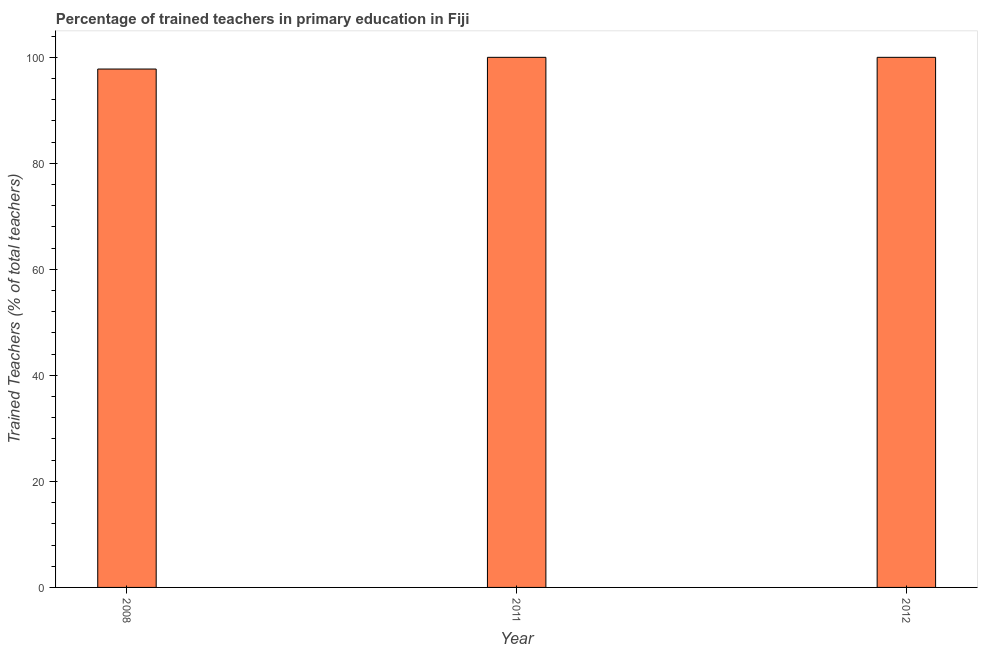Does the graph contain grids?
Offer a terse response. No. What is the title of the graph?
Offer a very short reply. Percentage of trained teachers in primary education in Fiji. What is the label or title of the X-axis?
Make the answer very short. Year. What is the label or title of the Y-axis?
Give a very brief answer. Trained Teachers (% of total teachers). What is the percentage of trained teachers in 2011?
Keep it short and to the point. 100. Across all years, what is the minimum percentage of trained teachers?
Offer a terse response. 97.79. What is the sum of the percentage of trained teachers?
Your response must be concise. 297.79. What is the difference between the percentage of trained teachers in 2008 and 2012?
Your answer should be compact. -2.21. What is the average percentage of trained teachers per year?
Your answer should be compact. 99.26. In how many years, is the percentage of trained teachers greater than 76 %?
Provide a short and direct response. 3. Do a majority of the years between 2008 and 2011 (inclusive) have percentage of trained teachers greater than 44 %?
Ensure brevity in your answer.  Yes. Is the sum of the percentage of trained teachers in 2011 and 2012 greater than the maximum percentage of trained teachers across all years?
Your answer should be very brief. Yes. What is the difference between the highest and the lowest percentage of trained teachers?
Keep it short and to the point. 2.21. How many years are there in the graph?
Offer a very short reply. 3. What is the difference between two consecutive major ticks on the Y-axis?
Provide a short and direct response. 20. Are the values on the major ticks of Y-axis written in scientific E-notation?
Give a very brief answer. No. What is the Trained Teachers (% of total teachers) of 2008?
Your answer should be very brief. 97.79. What is the Trained Teachers (% of total teachers) in 2012?
Your answer should be very brief. 100. What is the difference between the Trained Teachers (% of total teachers) in 2008 and 2011?
Your answer should be compact. -2.21. What is the difference between the Trained Teachers (% of total teachers) in 2008 and 2012?
Provide a succinct answer. -2.21. What is the ratio of the Trained Teachers (% of total teachers) in 2008 to that in 2012?
Your answer should be very brief. 0.98. 